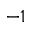<formula> <loc_0><loc_0><loc_500><loc_500>^ { - 1 }</formula> 